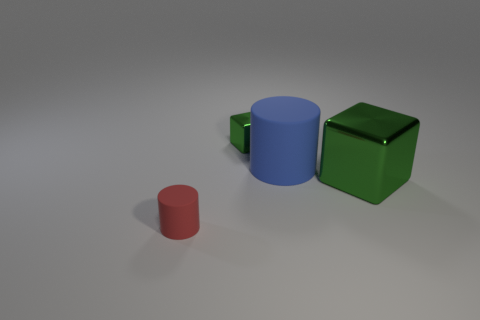Is the color of the tiny object that is on the right side of the small cylinder the same as the big shiny block?
Keep it short and to the point. Yes. How many objects are either small yellow blocks or green things on the right side of the tiny green shiny object?
Ensure brevity in your answer.  1. Does the tiny object that is right of the small cylinder have the same shape as the object on the left side of the tiny block?
Ensure brevity in your answer.  No. Is there anything else of the same color as the small shiny object?
Your response must be concise. Yes. What shape is the blue object that is made of the same material as the small red cylinder?
Your answer should be compact. Cylinder. There is a thing that is in front of the large blue object and behind the tiny rubber cylinder; what material is it?
Your answer should be compact. Metal. Is the small cube the same color as the large metallic cube?
Your answer should be compact. Yes. There is a metallic thing that is the same color as the tiny metal cube; what shape is it?
Offer a terse response. Cube. How many large things have the same shape as the small red object?
Keep it short and to the point. 1. The other cylinder that is made of the same material as the large cylinder is what size?
Keep it short and to the point. Small. 